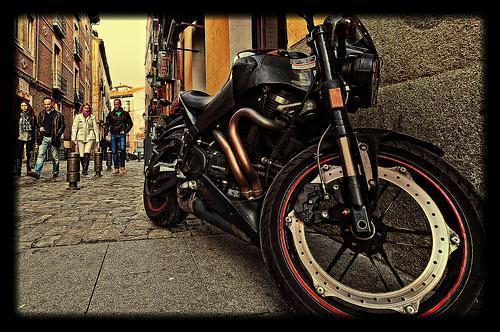How many bikes are there?
Give a very brief answer. 1. 